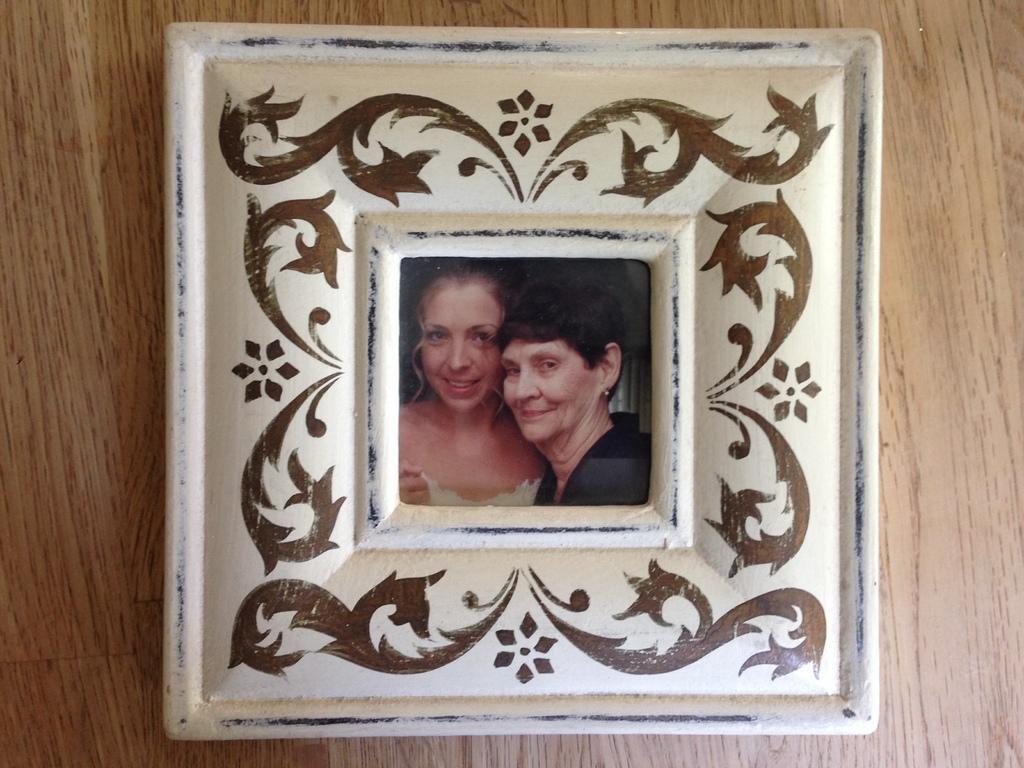How would you summarize this image in a sentence or two? In this image we can see a photo frame placed on the wooden surface. 